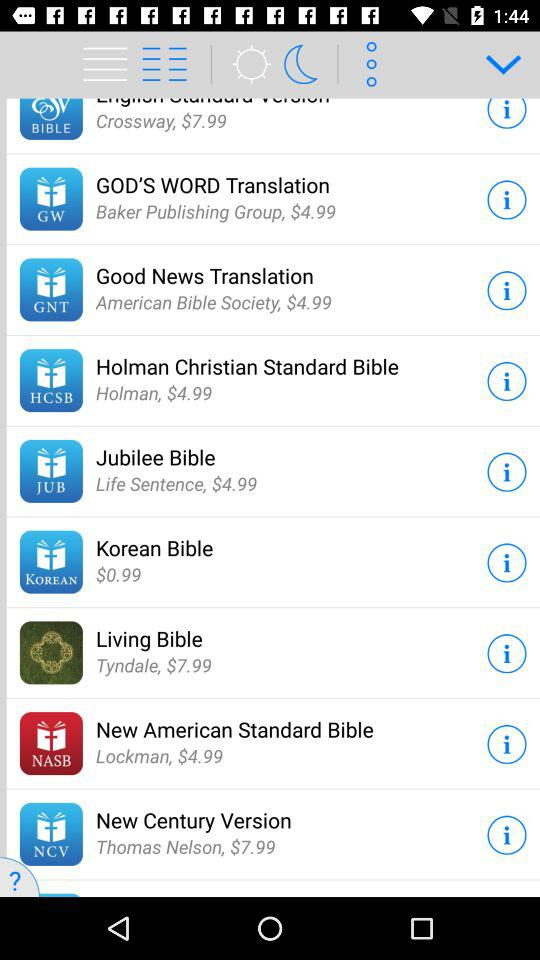How much does the "Living Bible" cost? The cost is $7.99. 